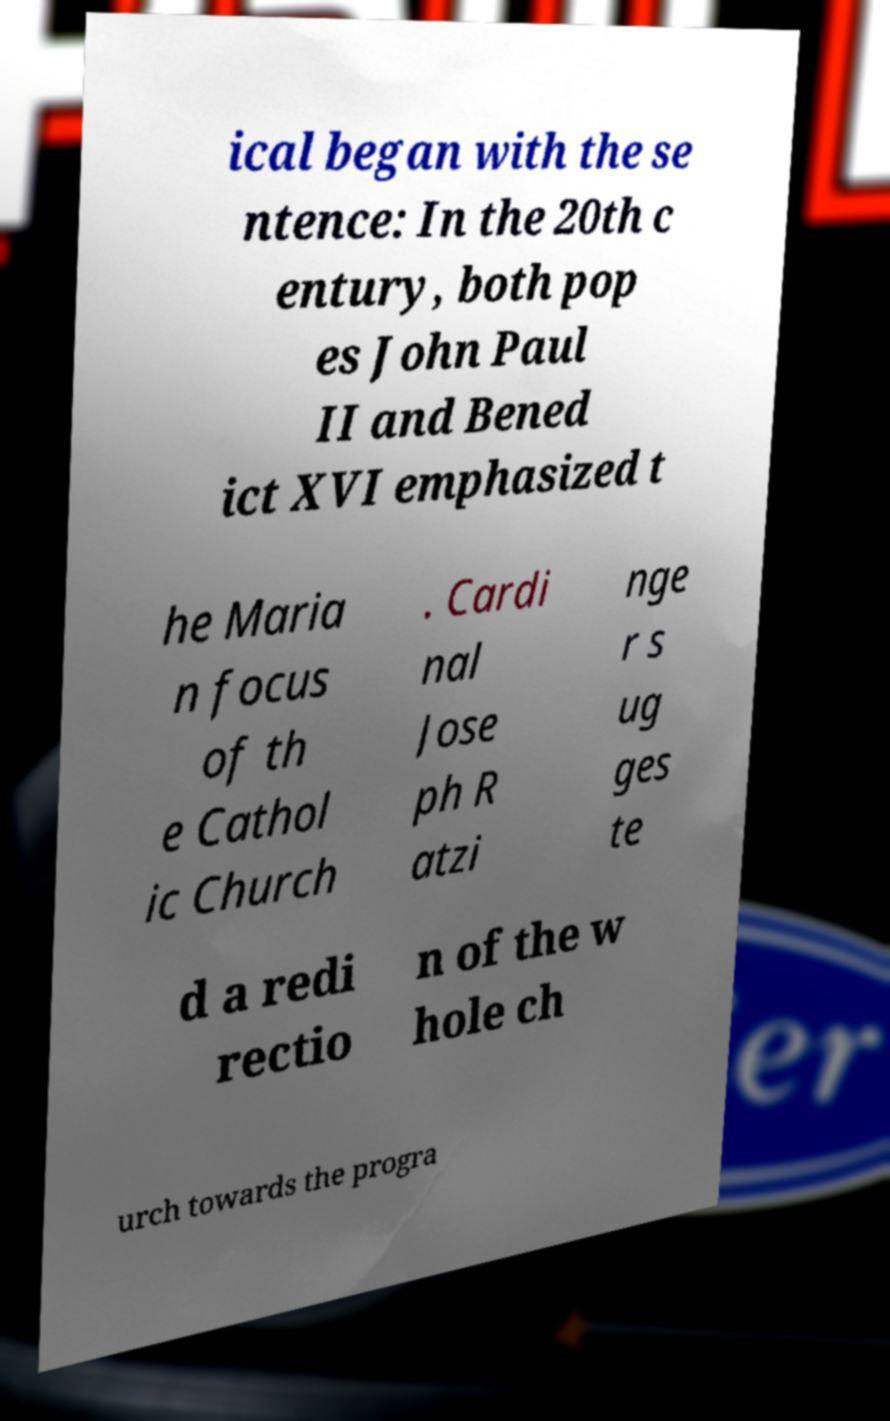Can you accurately transcribe the text from the provided image for me? ical began with the se ntence: In the 20th c entury, both pop es John Paul II and Bened ict XVI emphasized t he Maria n focus of th e Cathol ic Church . Cardi nal Jose ph R atzi nge r s ug ges te d a redi rectio n of the w hole ch urch towards the progra 